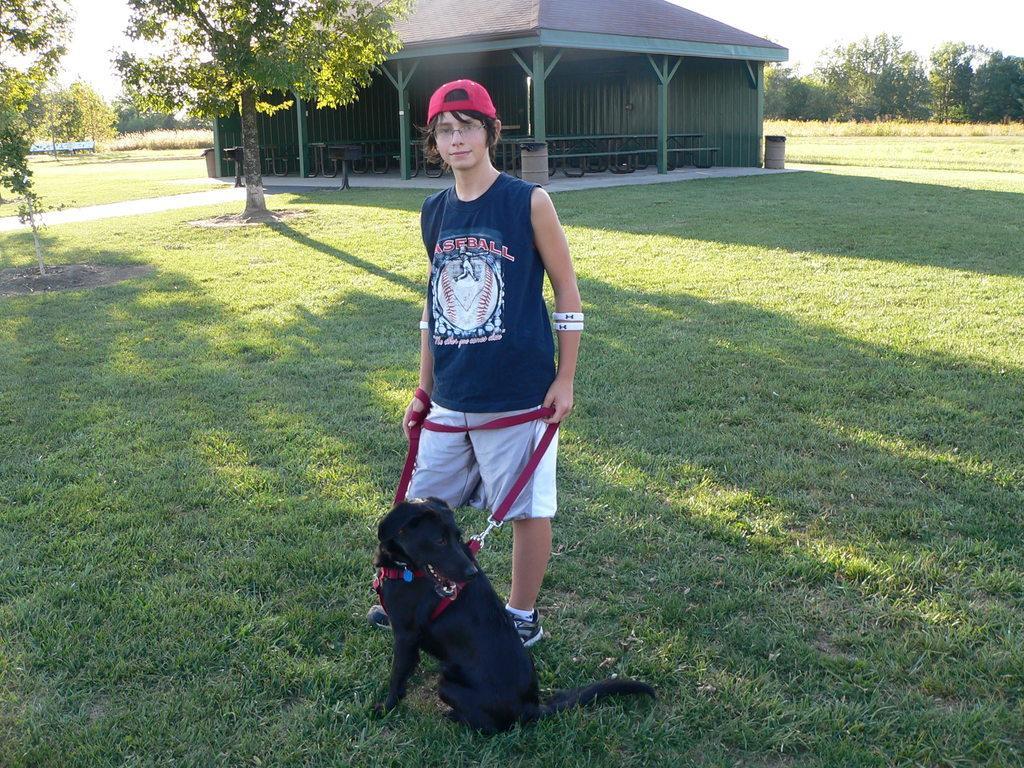How would you summarize this image in a sentence or two? The picture is taken outside of the house. It is a sunny day. One person is present in the picture holding a dog wearing a red cap and blue t-shirt, shorts and shoes. He´s standing on the grass behind him there are trees and one big house with chairs and benches and a dustbin. 